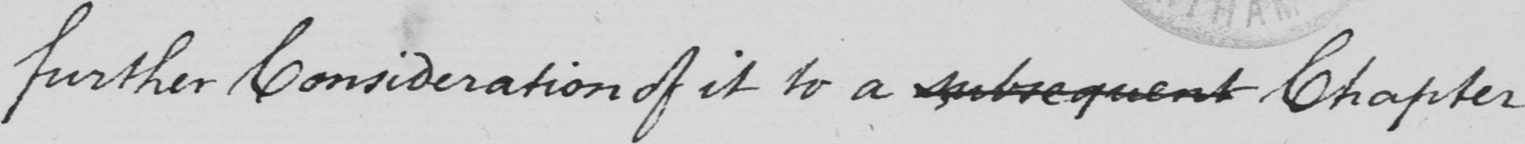Please transcribe the handwritten text in this image. Further consideration of it to a subsequent chapter 